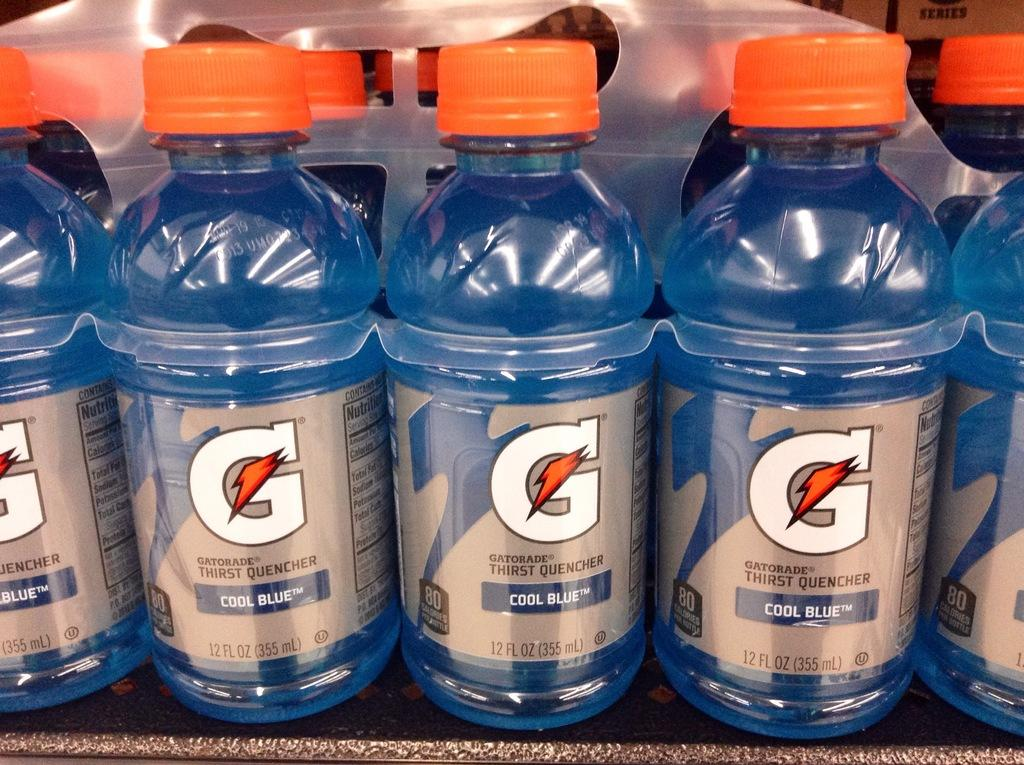<image>
Offer a succinct explanation of the picture presented. The bottles contain Gatorade Cool Blue flavor drink. 